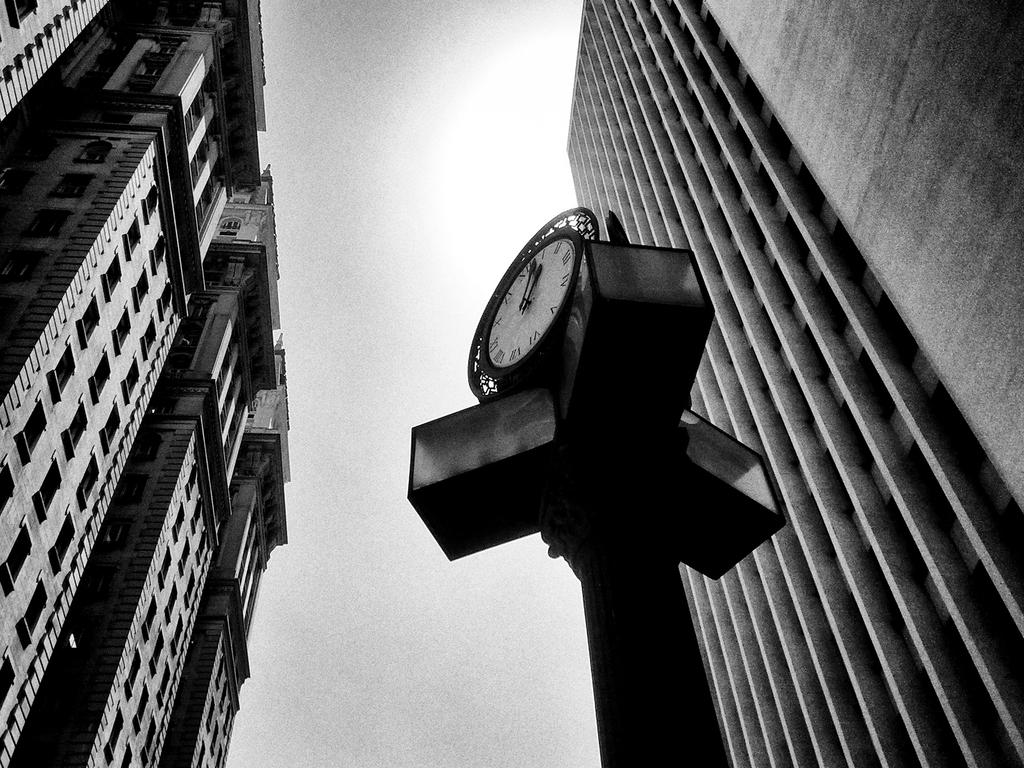What is the color scheme of the image? The image is black and white. What type of structures can be seen in the image? There are buildings in the image. What is located in the center of the image? There is a pole in the center of the image. What is attached to the pole? There is a clock attached to the pole. What is visible at the top of the image? The sky is visible at the top of the image. What type of soap is being advertised on the buildings in the image? There is no soap being advertised in the image; it features buildings, a pole, and a clock. 